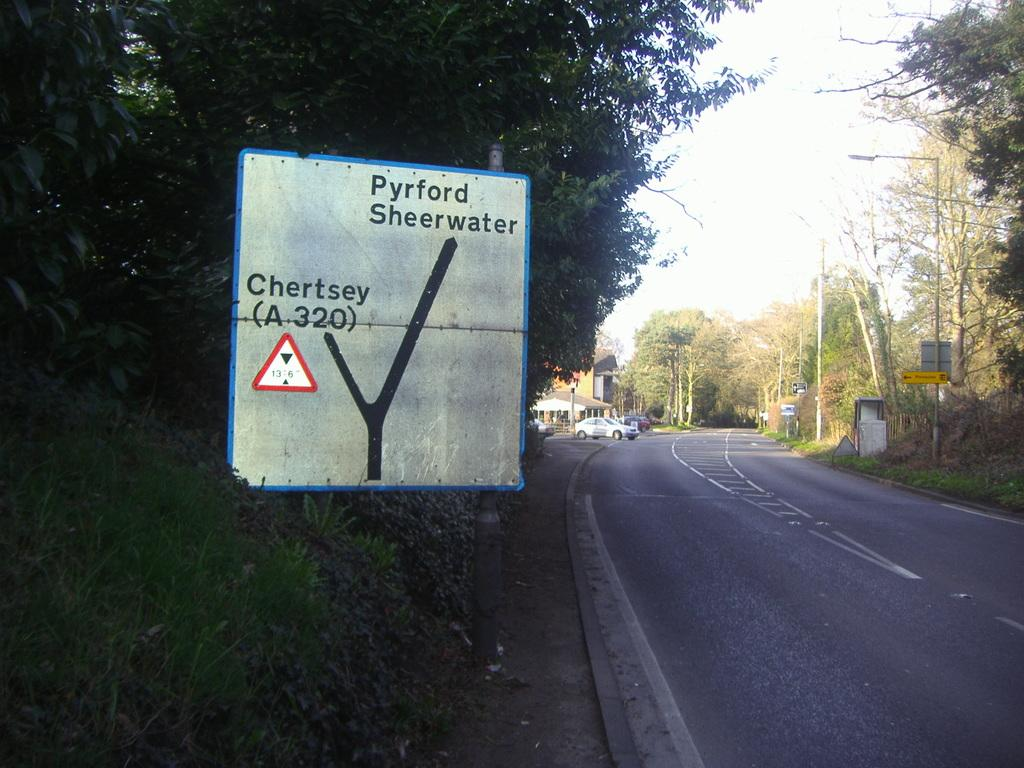What structures can be seen in the image? There are poles, cars, and houses in the image. Where is the sign pole located in the image? The sign pole is on the left side of the image. What type of vegetation is present in the image? There are trees around the area of the image. How many bananas are hanging from the poles in the image? There are no bananas present in the image; it features poles, cars, houses, and trees. What type of cream can be seen on the cars in the image? There is no cream visible on the cars in the image. 